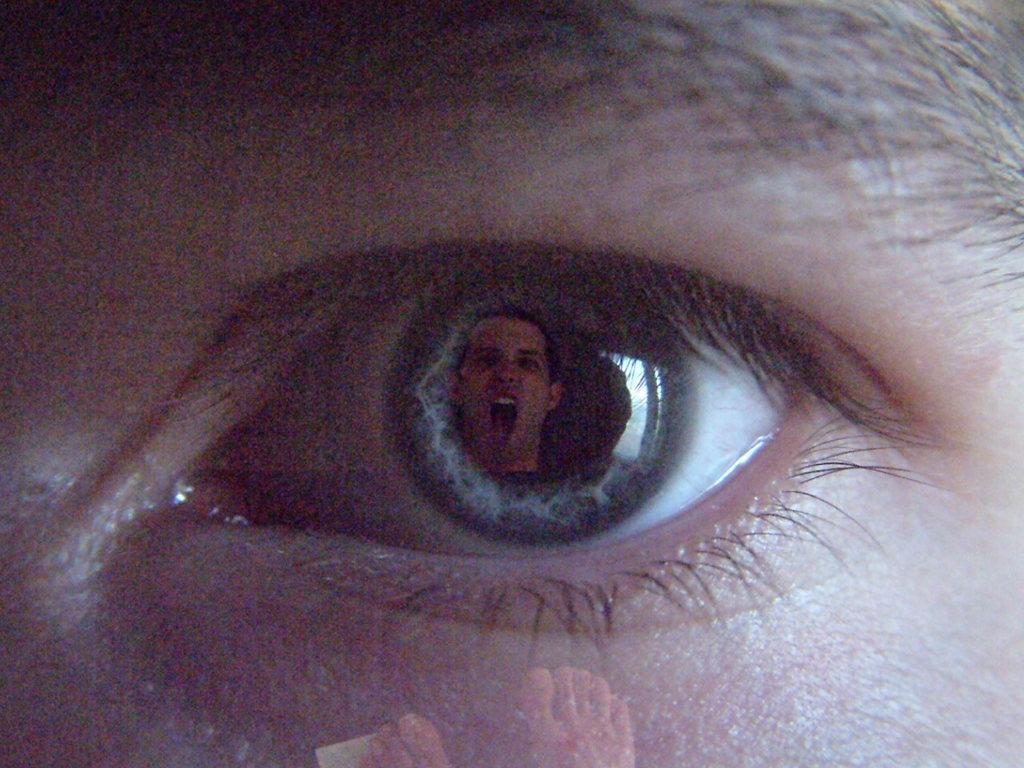Describe this image in one or two sentences. In this picture I can see an eye. From the eye I can see a person's face. In the below of the image I can see legs of a person. 